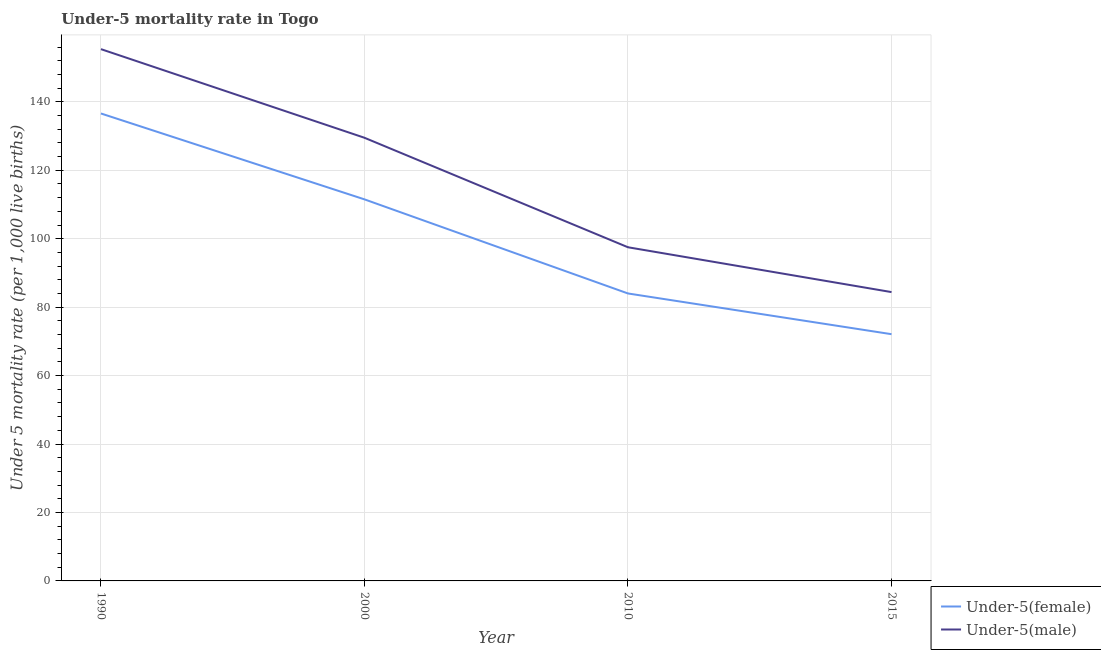How many different coloured lines are there?
Offer a terse response. 2. Does the line corresponding to under-5 male mortality rate intersect with the line corresponding to under-5 female mortality rate?
Ensure brevity in your answer.  No. Is the number of lines equal to the number of legend labels?
Your response must be concise. Yes. What is the under-5 female mortality rate in 2015?
Your answer should be compact. 72.1. Across all years, what is the maximum under-5 female mortality rate?
Make the answer very short. 136.6. Across all years, what is the minimum under-5 male mortality rate?
Offer a very short reply. 84.4. In which year was the under-5 female mortality rate minimum?
Offer a very short reply. 2015. What is the total under-5 female mortality rate in the graph?
Your response must be concise. 404.2. What is the difference between the under-5 male mortality rate in 1990 and that in 2010?
Your response must be concise. 57.9. What is the difference between the under-5 male mortality rate in 2000 and the under-5 female mortality rate in 2010?
Provide a succinct answer. 45.5. What is the average under-5 male mortality rate per year?
Your answer should be compact. 116.7. In the year 2015, what is the difference between the under-5 female mortality rate and under-5 male mortality rate?
Provide a succinct answer. -12.3. What is the ratio of the under-5 male mortality rate in 1990 to that in 2000?
Make the answer very short. 1.2. Is the difference between the under-5 male mortality rate in 2010 and 2015 greater than the difference between the under-5 female mortality rate in 2010 and 2015?
Your response must be concise. Yes. What is the difference between the highest and the second highest under-5 female mortality rate?
Your answer should be very brief. 25.1. What is the difference between the highest and the lowest under-5 female mortality rate?
Offer a very short reply. 64.5. In how many years, is the under-5 female mortality rate greater than the average under-5 female mortality rate taken over all years?
Make the answer very short. 2. Does the under-5 female mortality rate monotonically increase over the years?
Make the answer very short. No. Does the graph contain grids?
Provide a short and direct response. Yes. Where does the legend appear in the graph?
Keep it short and to the point. Bottom right. What is the title of the graph?
Give a very brief answer. Under-5 mortality rate in Togo. Does "Commercial service exports" appear as one of the legend labels in the graph?
Your answer should be very brief. No. What is the label or title of the X-axis?
Make the answer very short. Year. What is the label or title of the Y-axis?
Provide a succinct answer. Under 5 mortality rate (per 1,0 live births). What is the Under 5 mortality rate (per 1,000 live births) of Under-5(female) in 1990?
Provide a short and direct response. 136.6. What is the Under 5 mortality rate (per 1,000 live births) of Under-5(male) in 1990?
Ensure brevity in your answer.  155.4. What is the Under 5 mortality rate (per 1,000 live births) of Under-5(female) in 2000?
Keep it short and to the point. 111.5. What is the Under 5 mortality rate (per 1,000 live births) of Under-5(male) in 2000?
Provide a succinct answer. 129.5. What is the Under 5 mortality rate (per 1,000 live births) in Under-5(male) in 2010?
Your answer should be compact. 97.5. What is the Under 5 mortality rate (per 1,000 live births) in Under-5(female) in 2015?
Offer a very short reply. 72.1. What is the Under 5 mortality rate (per 1,000 live births) of Under-5(male) in 2015?
Provide a succinct answer. 84.4. Across all years, what is the maximum Under 5 mortality rate (per 1,000 live births) of Under-5(female)?
Your answer should be compact. 136.6. Across all years, what is the maximum Under 5 mortality rate (per 1,000 live births) in Under-5(male)?
Your answer should be very brief. 155.4. Across all years, what is the minimum Under 5 mortality rate (per 1,000 live births) in Under-5(female)?
Offer a terse response. 72.1. Across all years, what is the minimum Under 5 mortality rate (per 1,000 live births) in Under-5(male)?
Provide a short and direct response. 84.4. What is the total Under 5 mortality rate (per 1,000 live births) of Under-5(female) in the graph?
Give a very brief answer. 404.2. What is the total Under 5 mortality rate (per 1,000 live births) in Under-5(male) in the graph?
Keep it short and to the point. 466.8. What is the difference between the Under 5 mortality rate (per 1,000 live births) of Under-5(female) in 1990 and that in 2000?
Ensure brevity in your answer.  25.1. What is the difference between the Under 5 mortality rate (per 1,000 live births) of Under-5(male) in 1990 and that in 2000?
Offer a terse response. 25.9. What is the difference between the Under 5 mortality rate (per 1,000 live births) in Under-5(female) in 1990 and that in 2010?
Offer a terse response. 52.6. What is the difference between the Under 5 mortality rate (per 1,000 live births) of Under-5(male) in 1990 and that in 2010?
Keep it short and to the point. 57.9. What is the difference between the Under 5 mortality rate (per 1,000 live births) in Under-5(female) in 1990 and that in 2015?
Give a very brief answer. 64.5. What is the difference between the Under 5 mortality rate (per 1,000 live births) in Under-5(female) in 2000 and that in 2010?
Provide a succinct answer. 27.5. What is the difference between the Under 5 mortality rate (per 1,000 live births) of Under-5(male) in 2000 and that in 2010?
Keep it short and to the point. 32. What is the difference between the Under 5 mortality rate (per 1,000 live births) of Under-5(female) in 2000 and that in 2015?
Your answer should be compact. 39.4. What is the difference between the Under 5 mortality rate (per 1,000 live births) in Under-5(male) in 2000 and that in 2015?
Keep it short and to the point. 45.1. What is the difference between the Under 5 mortality rate (per 1,000 live births) of Under-5(female) in 2010 and that in 2015?
Keep it short and to the point. 11.9. What is the difference between the Under 5 mortality rate (per 1,000 live births) of Under-5(female) in 1990 and the Under 5 mortality rate (per 1,000 live births) of Under-5(male) in 2000?
Ensure brevity in your answer.  7.1. What is the difference between the Under 5 mortality rate (per 1,000 live births) in Under-5(female) in 1990 and the Under 5 mortality rate (per 1,000 live births) in Under-5(male) in 2010?
Your answer should be very brief. 39.1. What is the difference between the Under 5 mortality rate (per 1,000 live births) of Under-5(female) in 1990 and the Under 5 mortality rate (per 1,000 live births) of Under-5(male) in 2015?
Provide a short and direct response. 52.2. What is the difference between the Under 5 mortality rate (per 1,000 live births) in Under-5(female) in 2000 and the Under 5 mortality rate (per 1,000 live births) in Under-5(male) in 2015?
Provide a short and direct response. 27.1. What is the average Under 5 mortality rate (per 1,000 live births) in Under-5(female) per year?
Offer a terse response. 101.05. What is the average Under 5 mortality rate (per 1,000 live births) in Under-5(male) per year?
Keep it short and to the point. 116.7. In the year 1990, what is the difference between the Under 5 mortality rate (per 1,000 live births) of Under-5(female) and Under 5 mortality rate (per 1,000 live births) of Under-5(male)?
Provide a short and direct response. -18.8. In the year 2000, what is the difference between the Under 5 mortality rate (per 1,000 live births) of Under-5(female) and Under 5 mortality rate (per 1,000 live births) of Under-5(male)?
Offer a terse response. -18. In the year 2010, what is the difference between the Under 5 mortality rate (per 1,000 live births) of Under-5(female) and Under 5 mortality rate (per 1,000 live births) of Under-5(male)?
Your answer should be compact. -13.5. What is the ratio of the Under 5 mortality rate (per 1,000 live births) of Under-5(female) in 1990 to that in 2000?
Offer a terse response. 1.23. What is the ratio of the Under 5 mortality rate (per 1,000 live births) in Under-5(male) in 1990 to that in 2000?
Offer a terse response. 1.2. What is the ratio of the Under 5 mortality rate (per 1,000 live births) in Under-5(female) in 1990 to that in 2010?
Provide a succinct answer. 1.63. What is the ratio of the Under 5 mortality rate (per 1,000 live births) of Under-5(male) in 1990 to that in 2010?
Your answer should be compact. 1.59. What is the ratio of the Under 5 mortality rate (per 1,000 live births) of Under-5(female) in 1990 to that in 2015?
Your response must be concise. 1.89. What is the ratio of the Under 5 mortality rate (per 1,000 live births) in Under-5(male) in 1990 to that in 2015?
Your answer should be compact. 1.84. What is the ratio of the Under 5 mortality rate (per 1,000 live births) in Under-5(female) in 2000 to that in 2010?
Make the answer very short. 1.33. What is the ratio of the Under 5 mortality rate (per 1,000 live births) in Under-5(male) in 2000 to that in 2010?
Offer a terse response. 1.33. What is the ratio of the Under 5 mortality rate (per 1,000 live births) in Under-5(female) in 2000 to that in 2015?
Make the answer very short. 1.55. What is the ratio of the Under 5 mortality rate (per 1,000 live births) in Under-5(male) in 2000 to that in 2015?
Provide a succinct answer. 1.53. What is the ratio of the Under 5 mortality rate (per 1,000 live births) of Under-5(female) in 2010 to that in 2015?
Keep it short and to the point. 1.17. What is the ratio of the Under 5 mortality rate (per 1,000 live births) of Under-5(male) in 2010 to that in 2015?
Provide a short and direct response. 1.16. What is the difference between the highest and the second highest Under 5 mortality rate (per 1,000 live births) in Under-5(female)?
Your answer should be very brief. 25.1. What is the difference between the highest and the second highest Under 5 mortality rate (per 1,000 live births) of Under-5(male)?
Offer a very short reply. 25.9. What is the difference between the highest and the lowest Under 5 mortality rate (per 1,000 live births) in Under-5(female)?
Make the answer very short. 64.5. What is the difference between the highest and the lowest Under 5 mortality rate (per 1,000 live births) in Under-5(male)?
Make the answer very short. 71. 